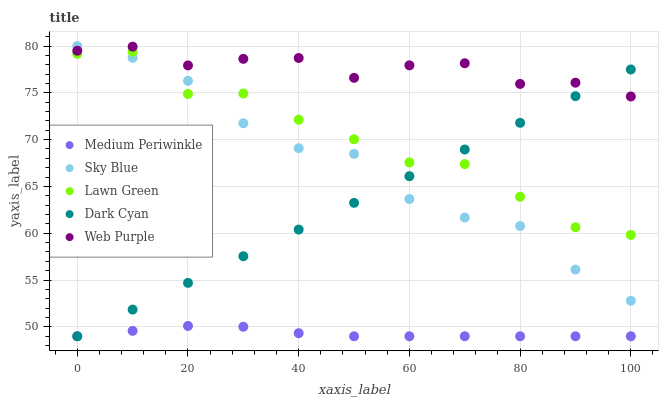Does Medium Periwinkle have the minimum area under the curve?
Answer yes or no. Yes. Does Web Purple have the maximum area under the curve?
Answer yes or no. Yes. Does Sky Blue have the minimum area under the curve?
Answer yes or no. No. Does Sky Blue have the maximum area under the curve?
Answer yes or no. No. Is Dark Cyan the smoothest?
Answer yes or no. Yes. Is Lawn Green the roughest?
Answer yes or no. Yes. Is Sky Blue the smoothest?
Answer yes or no. No. Is Sky Blue the roughest?
Answer yes or no. No. Does Dark Cyan have the lowest value?
Answer yes or no. Yes. Does Sky Blue have the lowest value?
Answer yes or no. No. Does Sky Blue have the highest value?
Answer yes or no. Yes. Does Web Purple have the highest value?
Answer yes or no. No. Is Medium Periwinkle less than Web Purple?
Answer yes or no. Yes. Is Web Purple greater than Lawn Green?
Answer yes or no. Yes. Does Lawn Green intersect Dark Cyan?
Answer yes or no. Yes. Is Lawn Green less than Dark Cyan?
Answer yes or no. No. Is Lawn Green greater than Dark Cyan?
Answer yes or no. No. Does Medium Periwinkle intersect Web Purple?
Answer yes or no. No. 